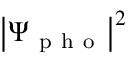<formula> <loc_0><loc_0><loc_500><loc_500>\left | \Psi _ { p h o } \right | ^ { 2 }</formula> 